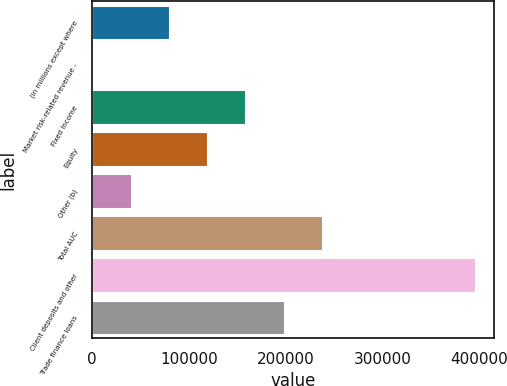Convert chart to OTSL. <chart><loc_0><loc_0><loc_500><loc_500><bar_chart><fcel>(in millions except where<fcel>Market risk-related revenue -<fcel>Fixed Income<fcel>Equity<fcel>Other (b)<fcel>Total AUC<fcel>Client deposits and other<fcel>Trade finance loans<nl><fcel>79066.6<fcel>9<fcel>158124<fcel>118595<fcel>39537.8<fcel>237182<fcel>395297<fcel>197653<nl></chart> 